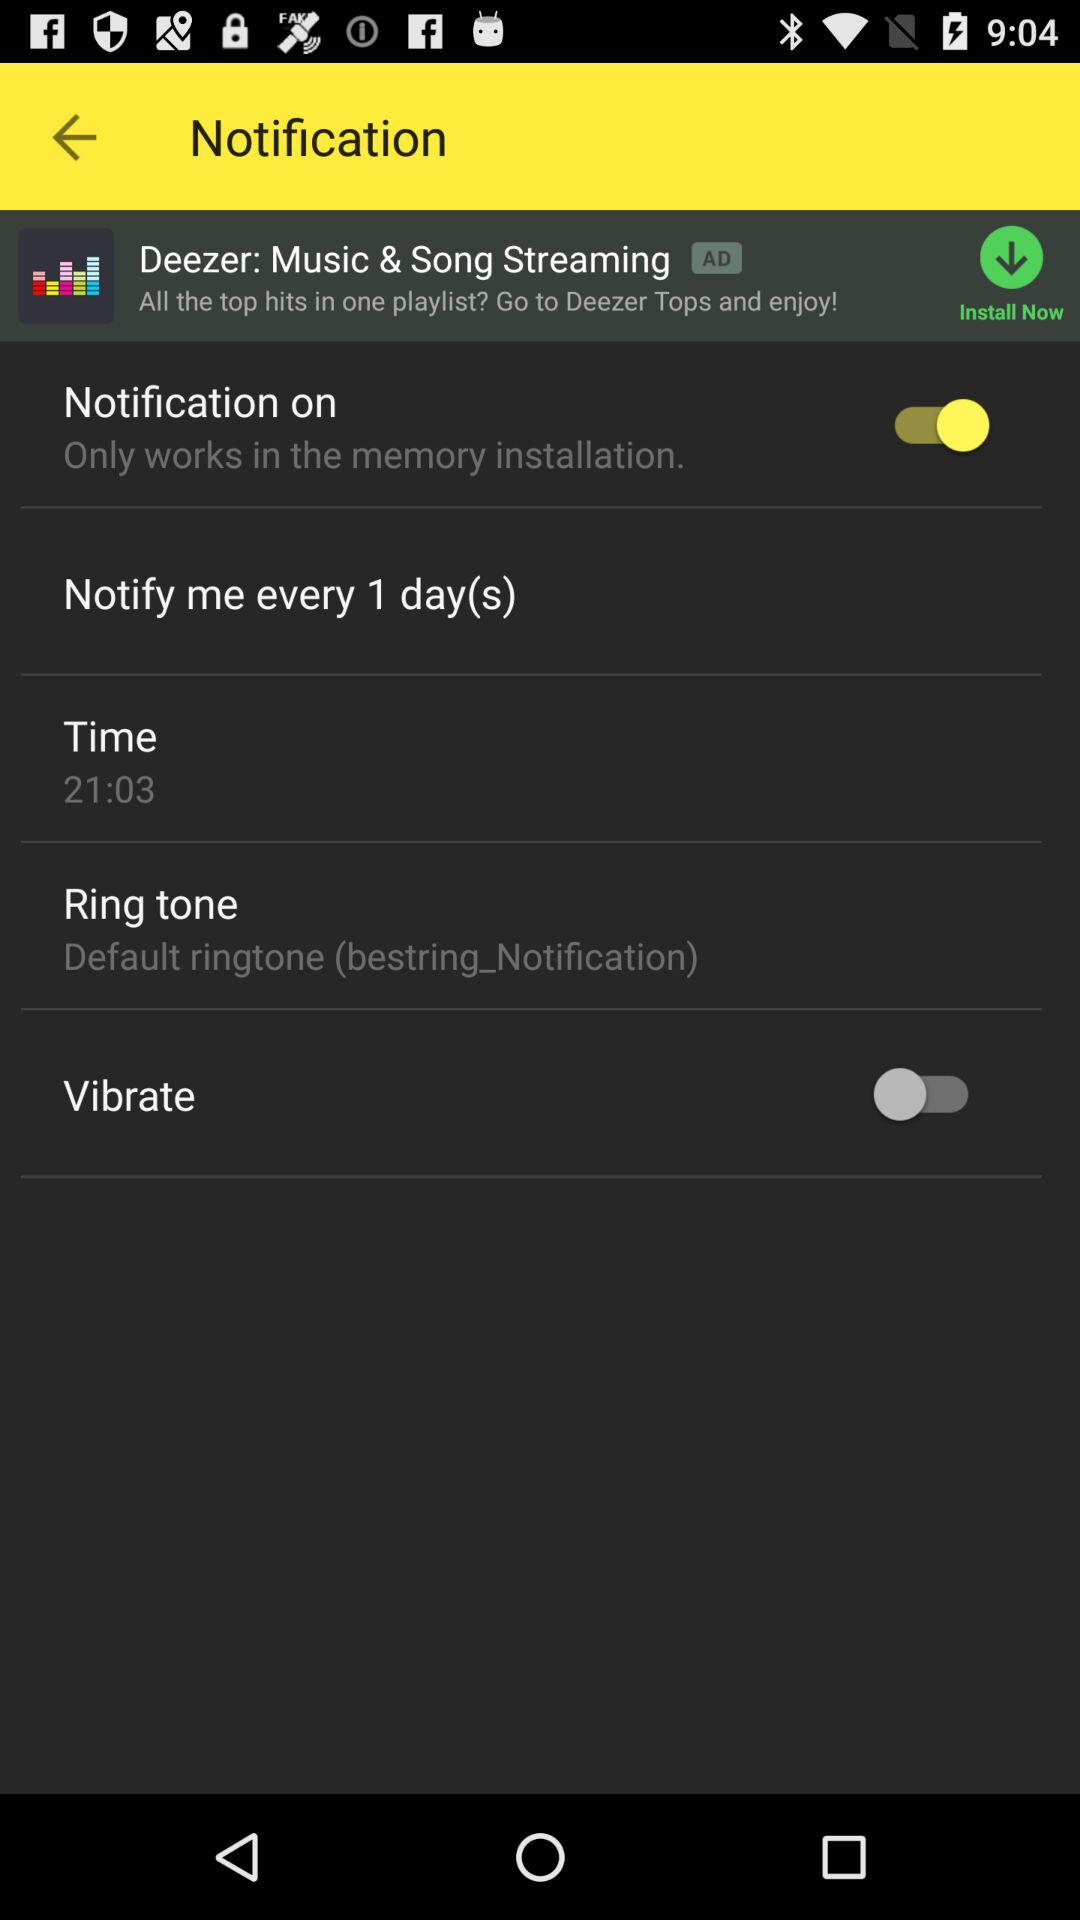What's the status of "Vibrate"? The status is "off". 